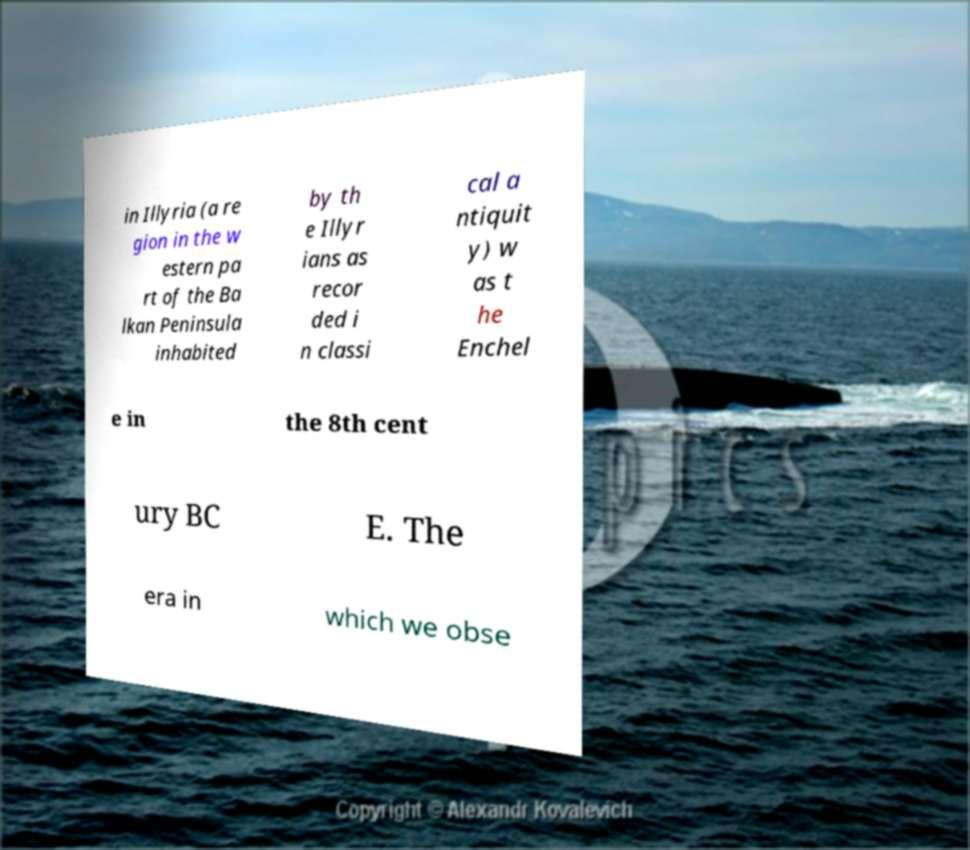Can you read and provide the text displayed in the image?This photo seems to have some interesting text. Can you extract and type it out for me? in Illyria (a re gion in the w estern pa rt of the Ba lkan Peninsula inhabited by th e Illyr ians as recor ded i n classi cal a ntiquit y) w as t he Enchel e in the 8th cent ury BC E. The era in which we obse 